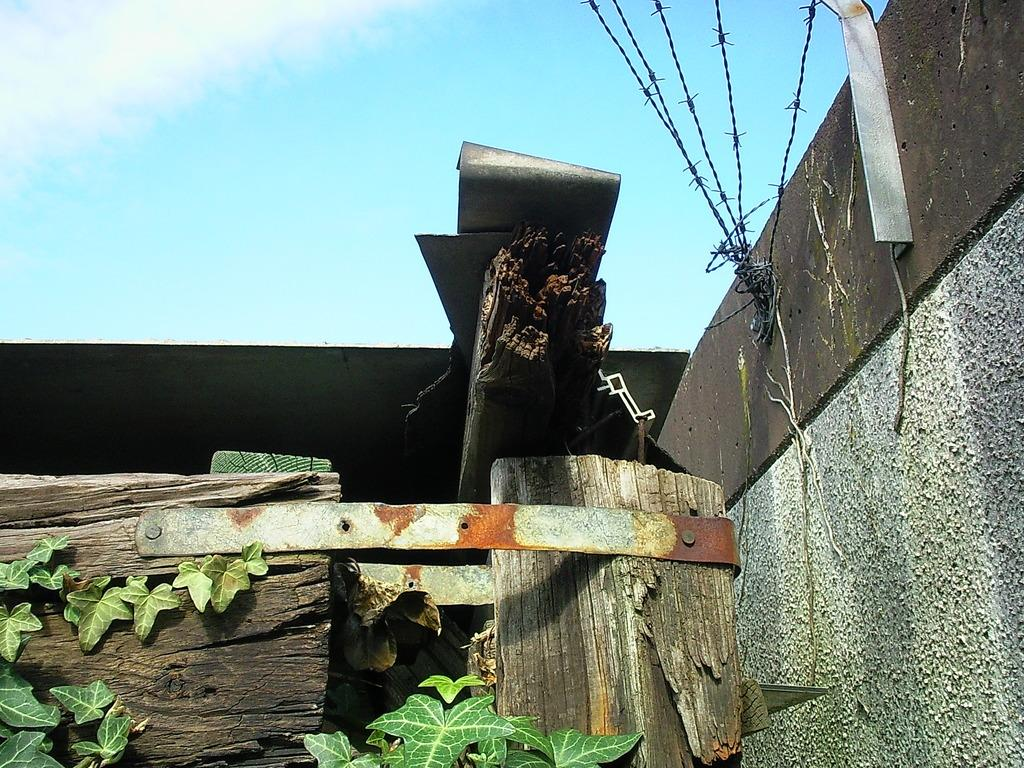How many wooden blocks can be seen in the image? There are 2 wooden blocks in the image. What connects the wooden blocks? The wooden blocks are attached by an iron rod. What color is the sky in the image? The sky is blue at the top of the image. What type of vegetation is visible at the bottom of the image? Leaves are visible at the bottom of the image. What type of clam is holding the wooden blocks together in the image? There are no clams present in the image; the wooden blocks are connected by an iron rod. What is the mind's role in the image? The image does not depict a mind or any mental processes; it shows wooden blocks connected by an iron rod, a blue sky, and leaves. 